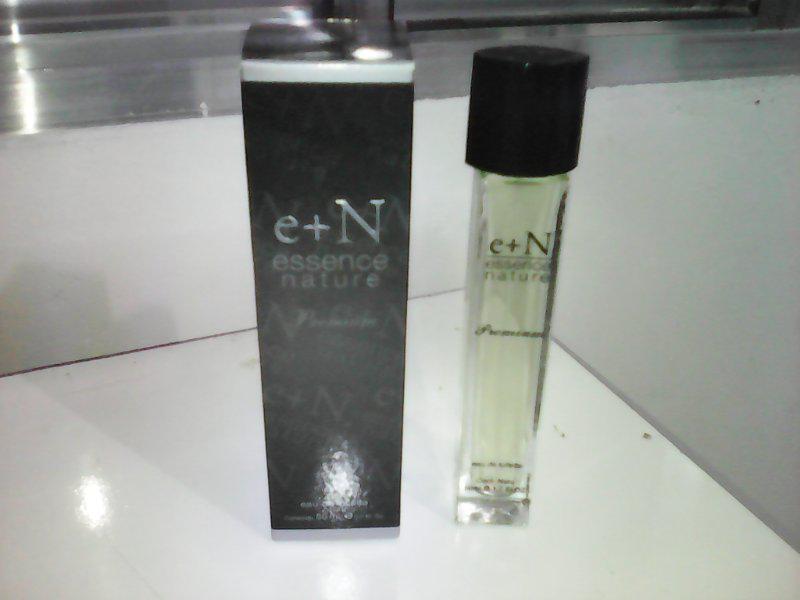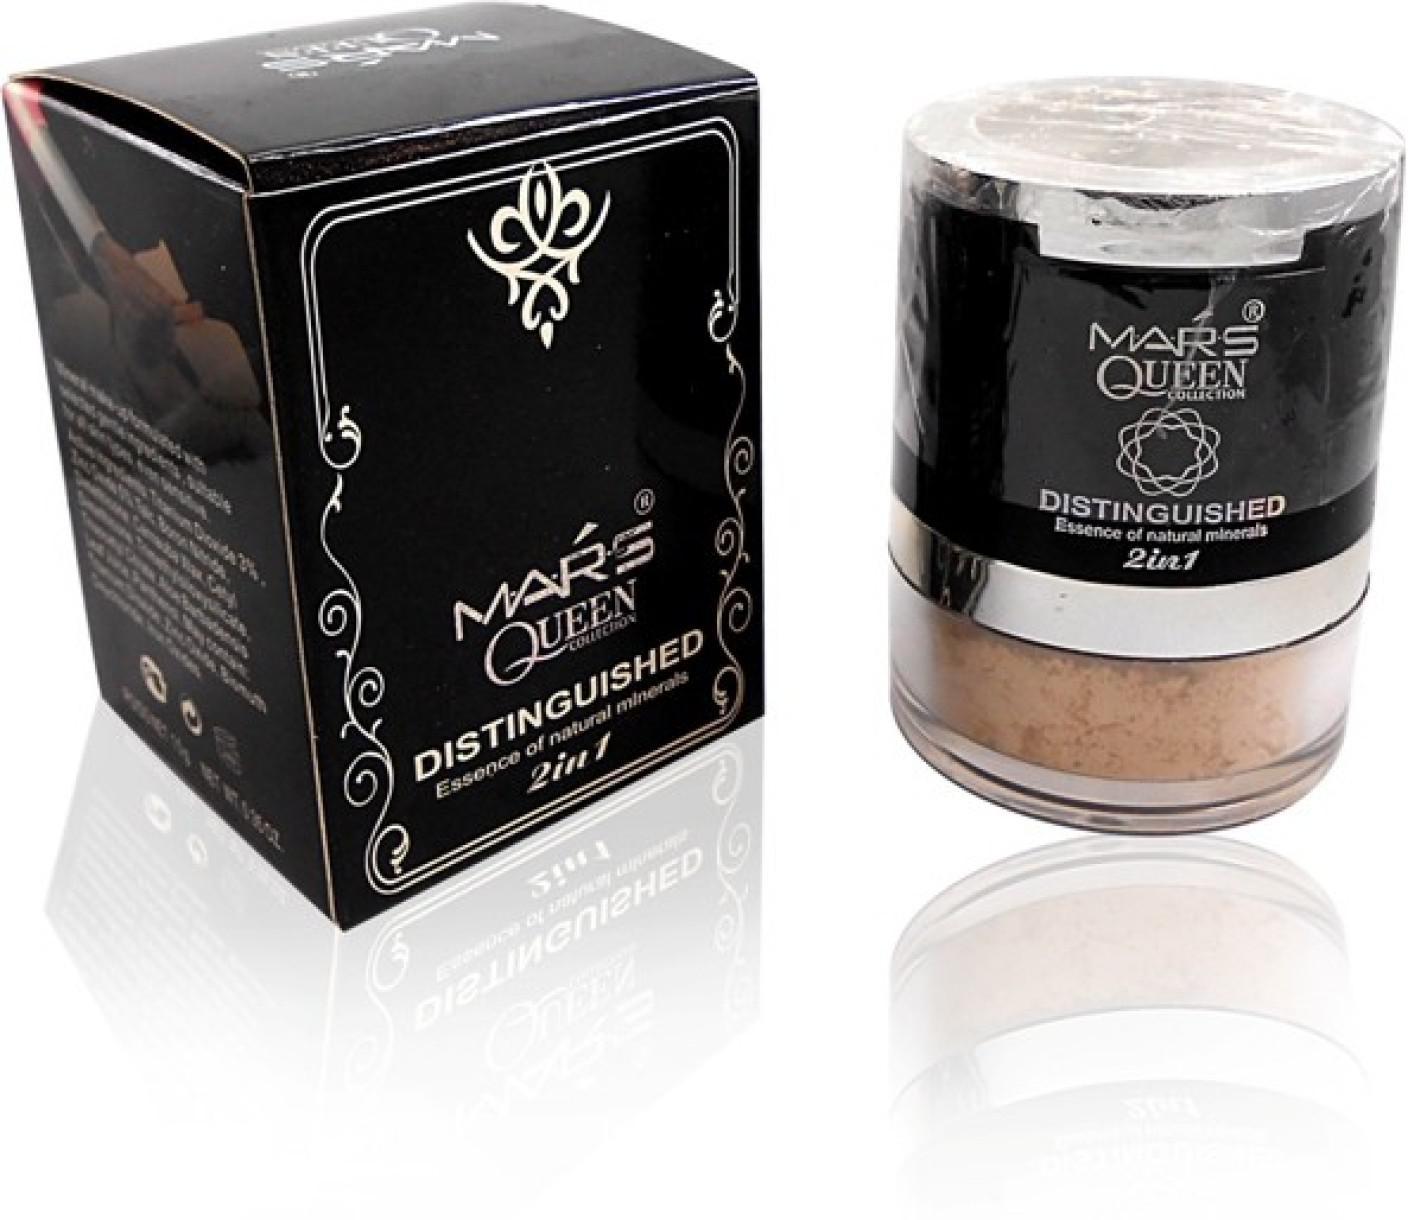The first image is the image on the left, the second image is the image on the right. For the images displayed, is the sentence "There are two long cylindrical perfume bottles next to their packaging box." factually correct? Answer yes or no. No. The first image is the image on the left, the second image is the image on the right. Considering the images on both sides, is "Two slender spray bottles with clear caps are shown to the right of their boxes." valid? Answer yes or no. No. 